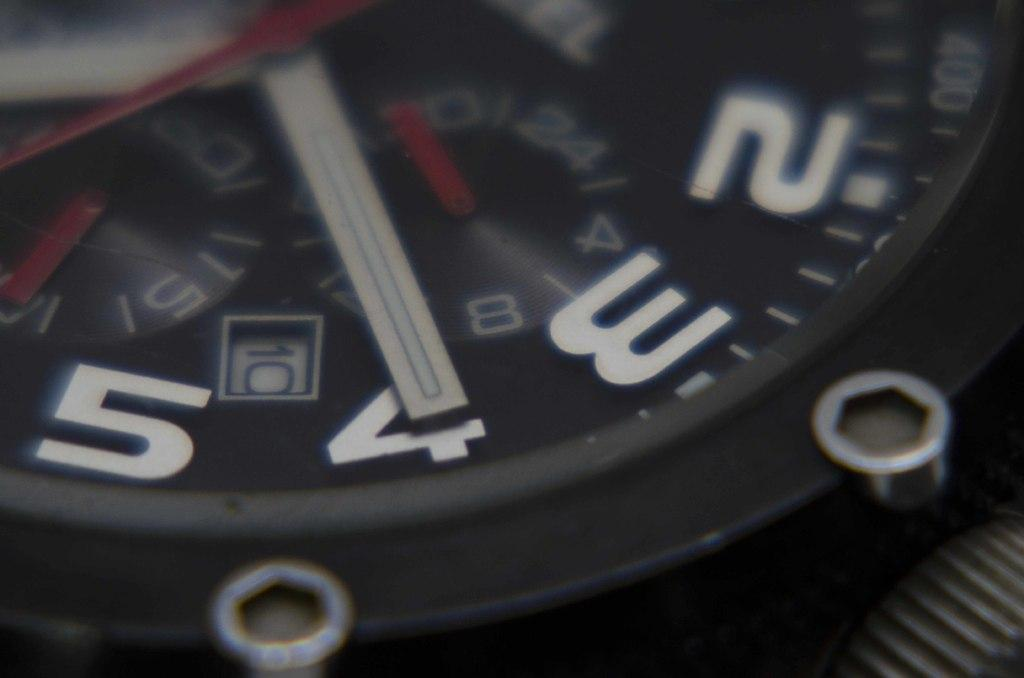Provide a one-sentence caption for the provided image. Wristwatch with the hand on the number 4. 